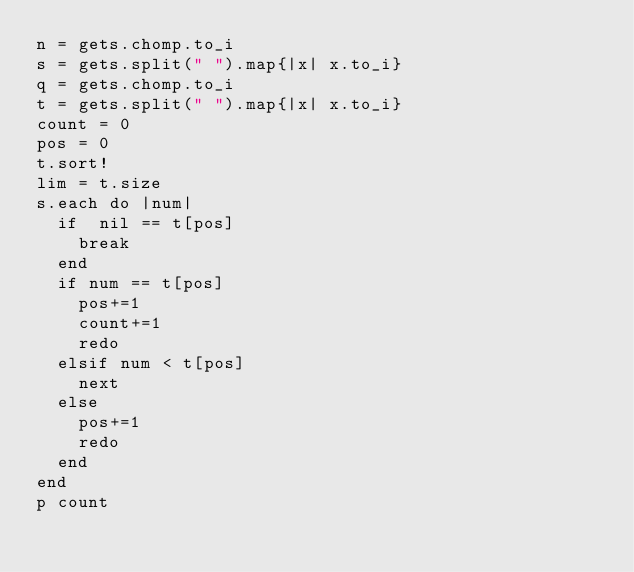<code> <loc_0><loc_0><loc_500><loc_500><_Ruby_>n = gets.chomp.to_i
s = gets.split(" ").map{|x| x.to_i}
q = gets.chomp.to_i
t = gets.split(" ").map{|x| x.to_i}
count = 0
pos = 0
t.sort!
lim = t.size
s.each do |num|
  if  nil == t[pos]
    break
  end
  if num == t[pos]
    pos+=1
    count+=1
    redo
  elsif num < t[pos]  
    next
  else
    pos+=1
    redo
  end
end
p count</code> 